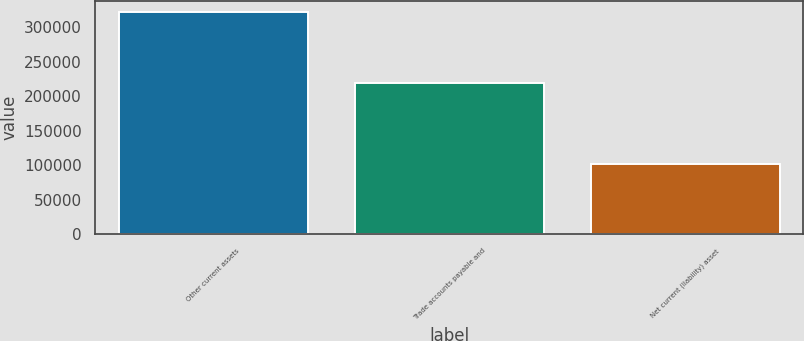<chart> <loc_0><loc_0><loc_500><loc_500><bar_chart><fcel>Other current assets<fcel>Trade accounts payable and<fcel>Net current (liability) asset<nl><fcel>322108<fcel>219676<fcel>102432<nl></chart> 